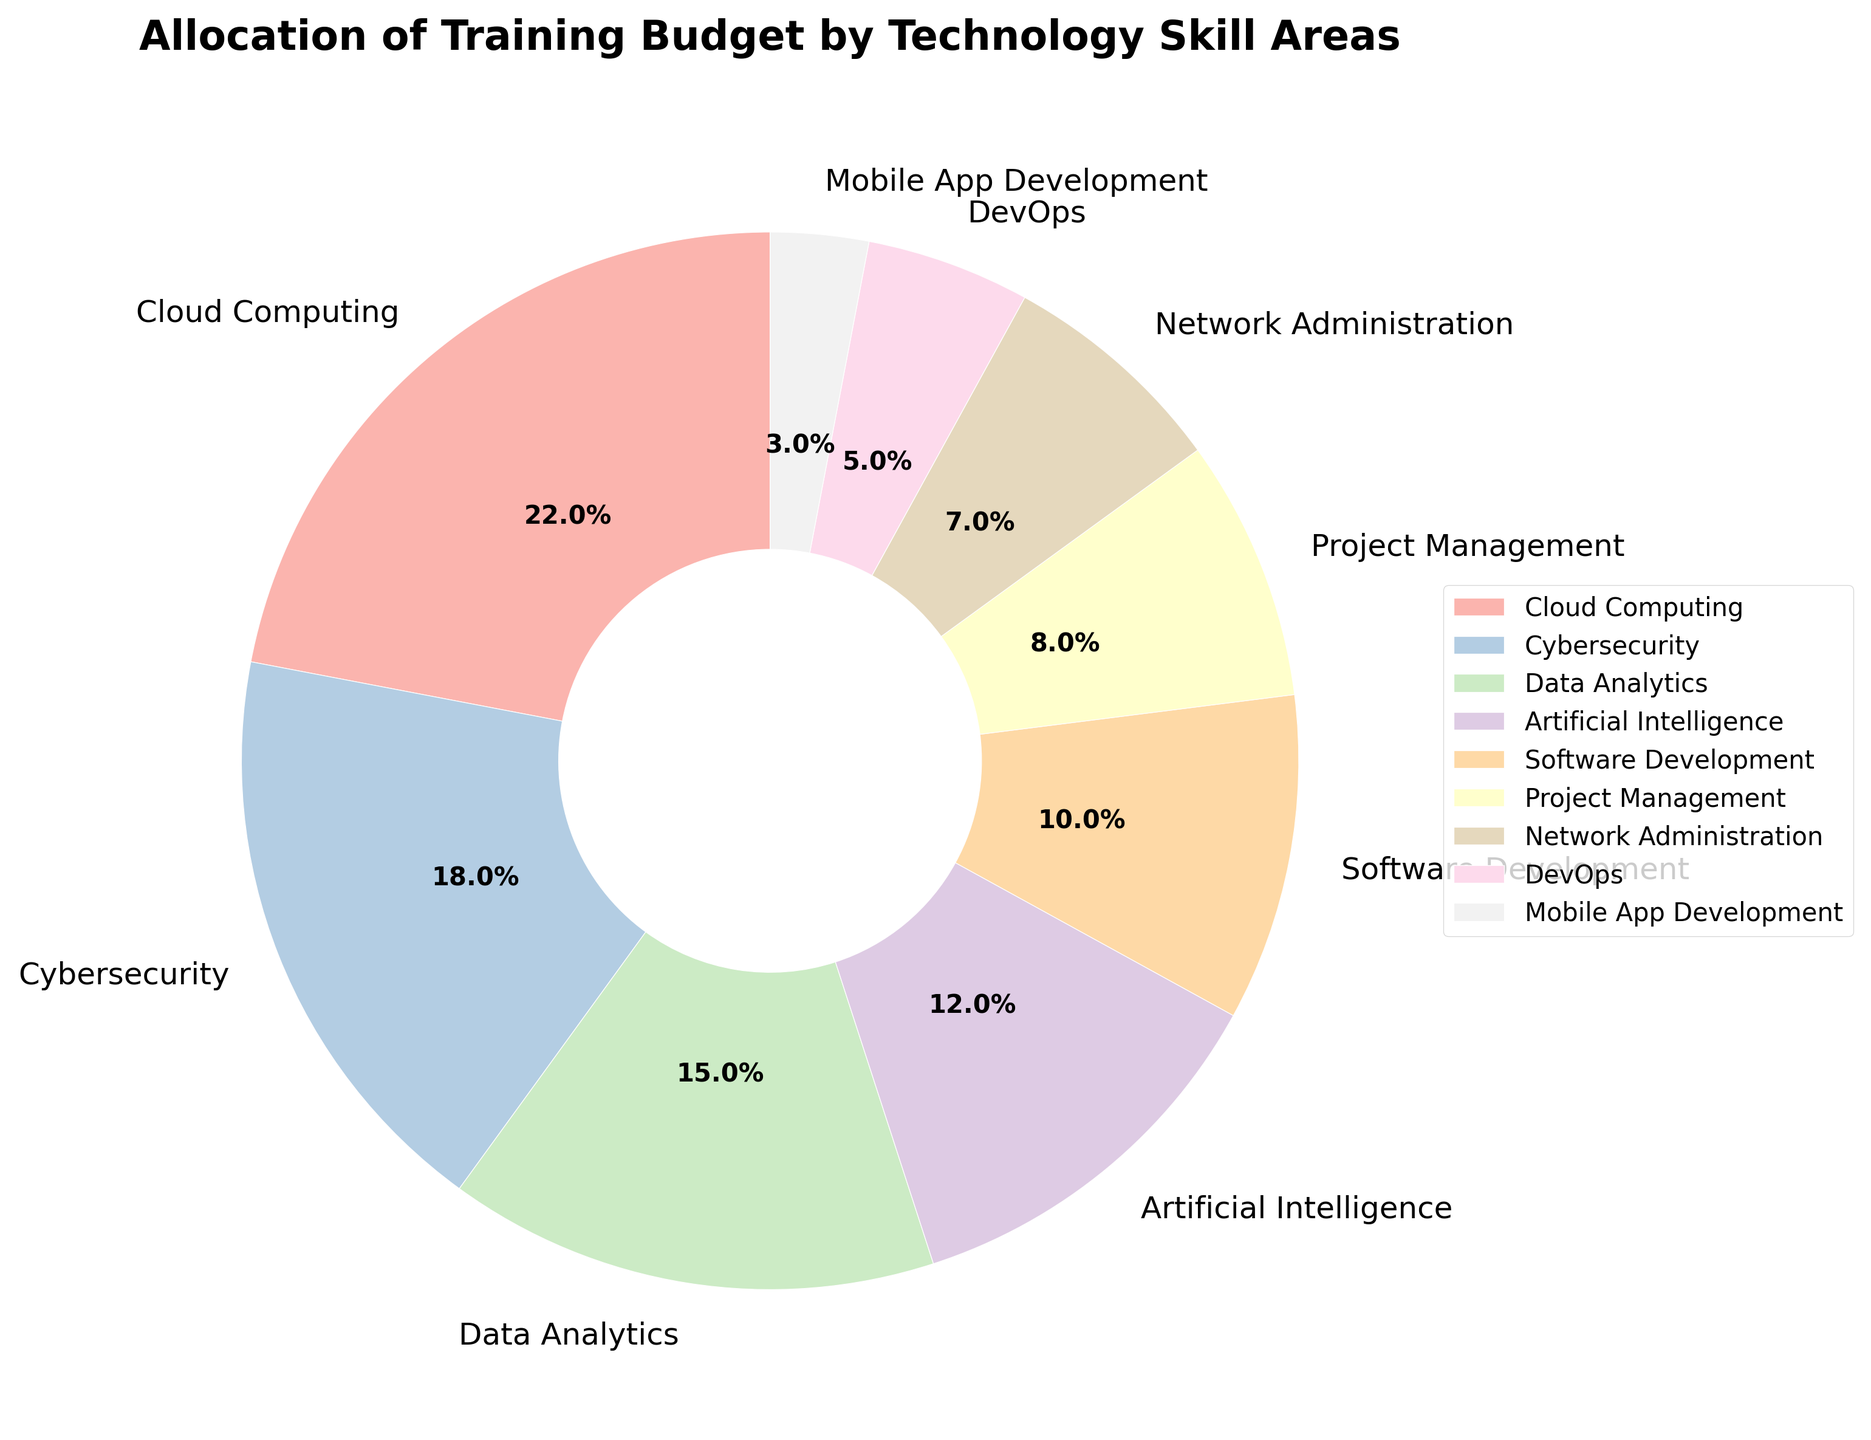Which technology skill area has the largest allocation of the training budget? The figure shows that 'Cloud Computing' has the largest segment in the pie chart.
Answer: Cloud Computing Which skill area receives more budget, Cybersecurity or Software Development? The pie chart indicates that 'Cybersecurity' receives 18% of the budget, whereas 'Software Development' receives 10%. Thus, 'Cybersecurity' receives more budget.
Answer: Cybersecurity What is the total percentage of the training budget allocated to Cloud Computing and Data Analytics combined? Cloud Computing receives 22% and Data Analytics receives 15%. Adding these together, 22% + 15% = 37%.
Answer: 37% Is the allocation for Mobile App Development less than that for Network Administration? The pie chart shows that 'Mobile App Development' has a 3% allocation, while 'Network Administration' has 7%. Thus, 'Mobile App Development' receives less.
Answer: Yes What is the difference in the budget allocation between Cybersecurity and Artificial Intelligence? Cybersecurity receives 18% and Artificial Intelligence receives 12%. The difference is 18% - 12% = 6%.
Answer: 6% Among the categories, which one has the smallest budget allocation, and what is its percentage? The smallest segment in the pie chart is labeled 'Mobile App Development', which has an allocation of 3%.
Answer: Mobile App Development, 3% Rank the top three skill areas in terms of budget allocation. Referring to the percentages in the pie chart: Cloud Computing (22%), Cybersecurity (18%), and Data Analytics (15%).
Answer: Cloud Computing, Cybersecurity, Data Analytics Which segment appears with approximately half the percentage of Cloud Computing's budget? Cloud Computing has 22%. About half of that would be 11%. 'Artificial Intelligence' with 12% is the closest to this value.
Answer: Artificial Intelligence Does Project Management receive a greater or lesser budget allocation than DevOps? Project Management is allocated 8%, while DevOps is allocated 5%. Therefore, Project Management receives a greater allocation.
Answer: Greater How much more budget is allocated to Network Administration than Mobile App Development? Network Administration is allocated 7%, while Mobile App Development is allocated 3%. The difference is 7% - 3% = 4%.
Answer: 4% 